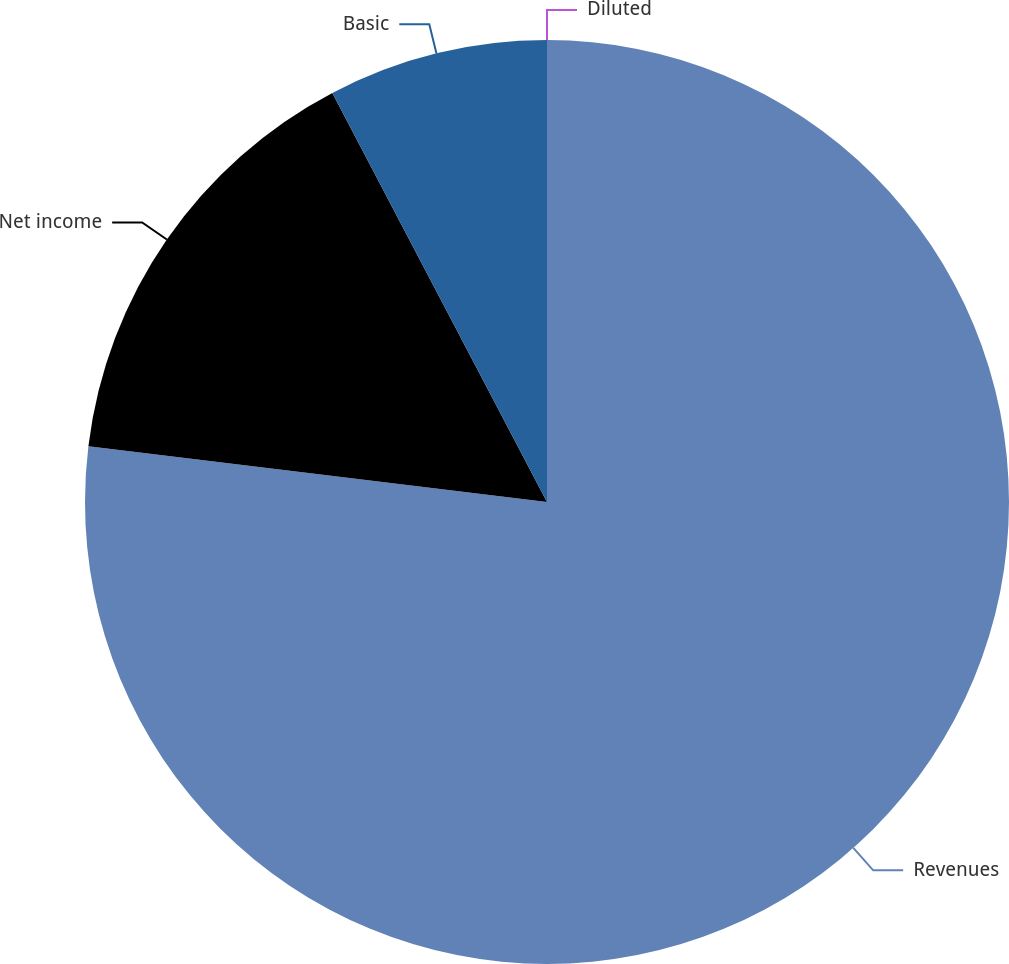Convert chart. <chart><loc_0><loc_0><loc_500><loc_500><pie_chart><fcel>Revenues<fcel>Net income<fcel>Basic<fcel>Diluted<nl><fcel>76.92%<fcel>15.38%<fcel>7.69%<fcel>0.0%<nl></chart> 